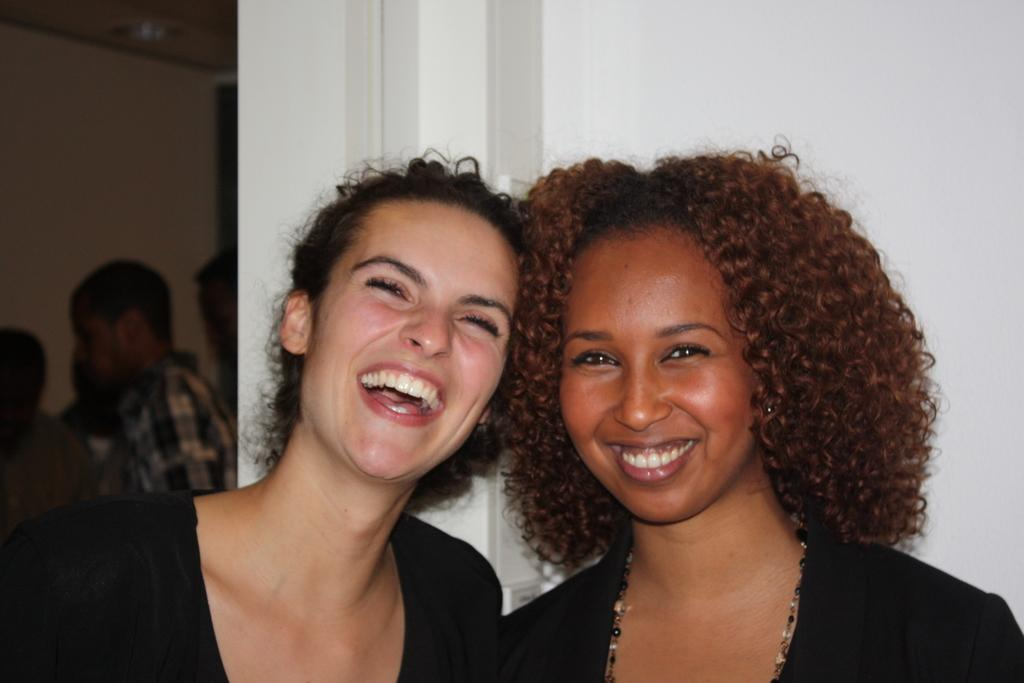Who is present in the front of the image? There are women in the front of the image. What expression do the women have? The women are smiling. What can be seen in the background of the image? There is a wall in the background of the image. Are there any other people visible in the image? Yes, there are persons in the background of the image. What type of memory is being sold at the market in the image? There is no market or memory present in the image; it features women in the front and a wall in the background. Can you tell me how many tramps are visible in the image? There are no tramps visible in the image. 